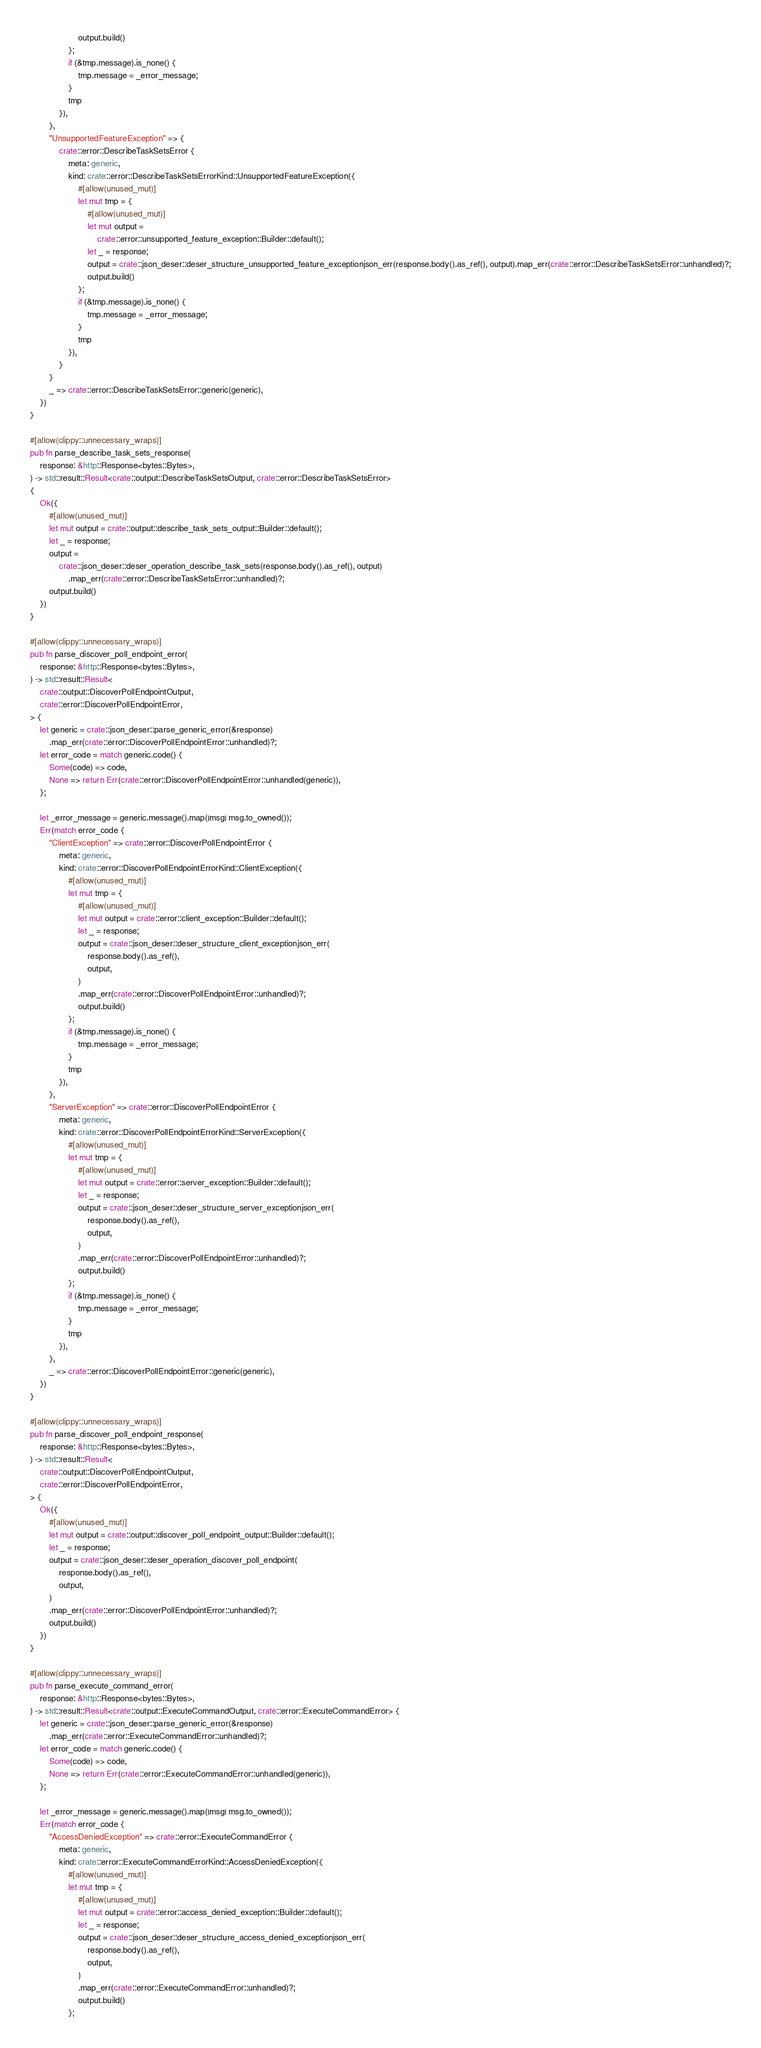<code> <loc_0><loc_0><loc_500><loc_500><_Rust_>                    output.build()
                };
                if (&tmp.message).is_none() {
                    tmp.message = _error_message;
                }
                tmp
            }),
        },
        "UnsupportedFeatureException" => {
            crate::error::DescribeTaskSetsError {
                meta: generic,
                kind: crate::error::DescribeTaskSetsErrorKind::UnsupportedFeatureException({
                    #[allow(unused_mut)]
                    let mut tmp = {
                        #[allow(unused_mut)]
                        let mut output =
                            crate::error::unsupported_feature_exception::Builder::default();
                        let _ = response;
                        output = crate::json_deser::deser_structure_unsupported_feature_exceptionjson_err(response.body().as_ref(), output).map_err(crate::error::DescribeTaskSetsError::unhandled)?;
                        output.build()
                    };
                    if (&tmp.message).is_none() {
                        tmp.message = _error_message;
                    }
                    tmp
                }),
            }
        }
        _ => crate::error::DescribeTaskSetsError::generic(generic),
    })
}

#[allow(clippy::unnecessary_wraps)]
pub fn parse_describe_task_sets_response(
    response: &http::Response<bytes::Bytes>,
) -> std::result::Result<crate::output::DescribeTaskSetsOutput, crate::error::DescribeTaskSetsError>
{
    Ok({
        #[allow(unused_mut)]
        let mut output = crate::output::describe_task_sets_output::Builder::default();
        let _ = response;
        output =
            crate::json_deser::deser_operation_describe_task_sets(response.body().as_ref(), output)
                .map_err(crate::error::DescribeTaskSetsError::unhandled)?;
        output.build()
    })
}

#[allow(clippy::unnecessary_wraps)]
pub fn parse_discover_poll_endpoint_error(
    response: &http::Response<bytes::Bytes>,
) -> std::result::Result<
    crate::output::DiscoverPollEndpointOutput,
    crate::error::DiscoverPollEndpointError,
> {
    let generic = crate::json_deser::parse_generic_error(&response)
        .map_err(crate::error::DiscoverPollEndpointError::unhandled)?;
    let error_code = match generic.code() {
        Some(code) => code,
        None => return Err(crate::error::DiscoverPollEndpointError::unhandled(generic)),
    };

    let _error_message = generic.message().map(|msg| msg.to_owned());
    Err(match error_code {
        "ClientException" => crate::error::DiscoverPollEndpointError {
            meta: generic,
            kind: crate::error::DiscoverPollEndpointErrorKind::ClientException({
                #[allow(unused_mut)]
                let mut tmp = {
                    #[allow(unused_mut)]
                    let mut output = crate::error::client_exception::Builder::default();
                    let _ = response;
                    output = crate::json_deser::deser_structure_client_exceptionjson_err(
                        response.body().as_ref(),
                        output,
                    )
                    .map_err(crate::error::DiscoverPollEndpointError::unhandled)?;
                    output.build()
                };
                if (&tmp.message).is_none() {
                    tmp.message = _error_message;
                }
                tmp
            }),
        },
        "ServerException" => crate::error::DiscoverPollEndpointError {
            meta: generic,
            kind: crate::error::DiscoverPollEndpointErrorKind::ServerException({
                #[allow(unused_mut)]
                let mut tmp = {
                    #[allow(unused_mut)]
                    let mut output = crate::error::server_exception::Builder::default();
                    let _ = response;
                    output = crate::json_deser::deser_structure_server_exceptionjson_err(
                        response.body().as_ref(),
                        output,
                    )
                    .map_err(crate::error::DiscoverPollEndpointError::unhandled)?;
                    output.build()
                };
                if (&tmp.message).is_none() {
                    tmp.message = _error_message;
                }
                tmp
            }),
        },
        _ => crate::error::DiscoverPollEndpointError::generic(generic),
    })
}

#[allow(clippy::unnecessary_wraps)]
pub fn parse_discover_poll_endpoint_response(
    response: &http::Response<bytes::Bytes>,
) -> std::result::Result<
    crate::output::DiscoverPollEndpointOutput,
    crate::error::DiscoverPollEndpointError,
> {
    Ok({
        #[allow(unused_mut)]
        let mut output = crate::output::discover_poll_endpoint_output::Builder::default();
        let _ = response;
        output = crate::json_deser::deser_operation_discover_poll_endpoint(
            response.body().as_ref(),
            output,
        )
        .map_err(crate::error::DiscoverPollEndpointError::unhandled)?;
        output.build()
    })
}

#[allow(clippy::unnecessary_wraps)]
pub fn parse_execute_command_error(
    response: &http::Response<bytes::Bytes>,
) -> std::result::Result<crate::output::ExecuteCommandOutput, crate::error::ExecuteCommandError> {
    let generic = crate::json_deser::parse_generic_error(&response)
        .map_err(crate::error::ExecuteCommandError::unhandled)?;
    let error_code = match generic.code() {
        Some(code) => code,
        None => return Err(crate::error::ExecuteCommandError::unhandled(generic)),
    };

    let _error_message = generic.message().map(|msg| msg.to_owned());
    Err(match error_code {
        "AccessDeniedException" => crate::error::ExecuteCommandError {
            meta: generic,
            kind: crate::error::ExecuteCommandErrorKind::AccessDeniedException({
                #[allow(unused_mut)]
                let mut tmp = {
                    #[allow(unused_mut)]
                    let mut output = crate::error::access_denied_exception::Builder::default();
                    let _ = response;
                    output = crate::json_deser::deser_structure_access_denied_exceptionjson_err(
                        response.body().as_ref(),
                        output,
                    )
                    .map_err(crate::error::ExecuteCommandError::unhandled)?;
                    output.build()
                };</code> 